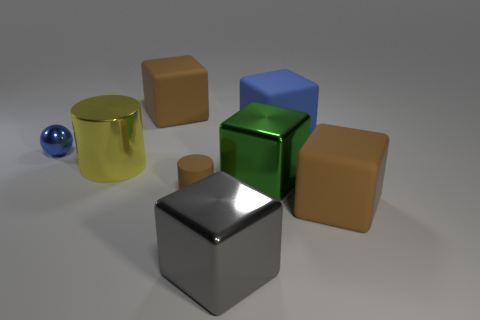Subtract all brown cubes. How many were subtracted if there are1brown cubes left? 1 Subtract all big green cubes. How many cubes are left? 4 Subtract all yellow balls. How many brown blocks are left? 2 Subtract all blue cubes. How many cubes are left? 4 Add 1 balls. How many objects exist? 9 Subtract 2 blocks. How many blocks are left? 3 Subtract all green blocks. Subtract all blue balls. How many blocks are left? 4 Subtract all balls. How many objects are left? 7 Subtract 0 cyan cylinders. How many objects are left? 8 Subtract all brown cubes. Subtract all large yellow cylinders. How many objects are left? 5 